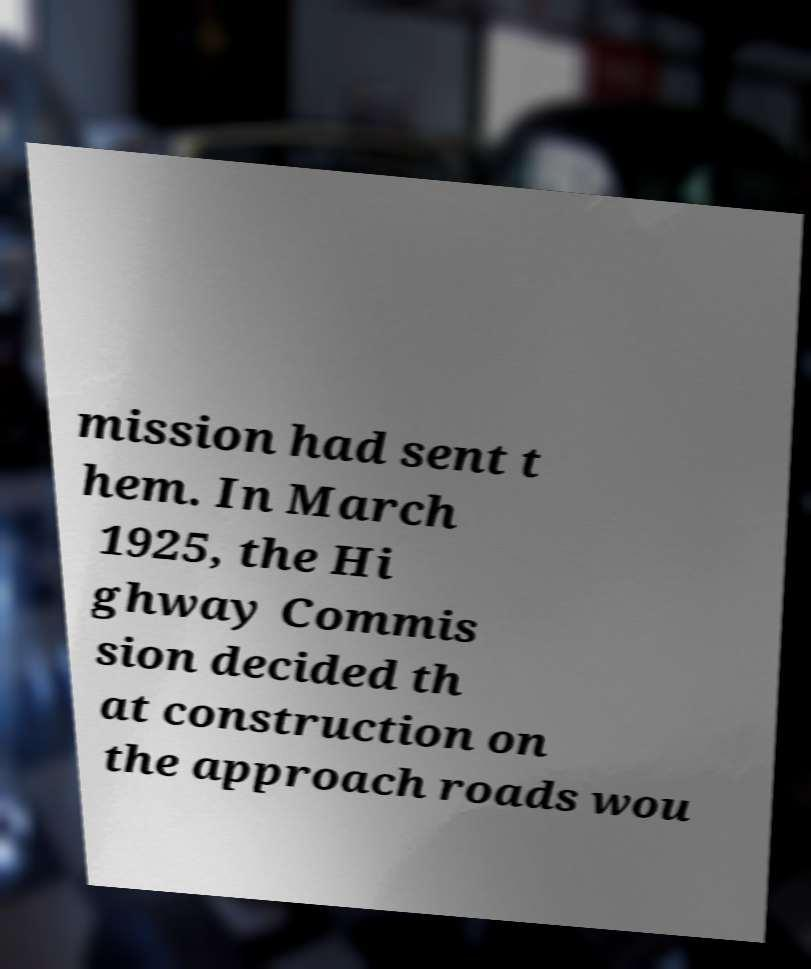I need the written content from this picture converted into text. Can you do that? mission had sent t hem. In March 1925, the Hi ghway Commis sion decided th at construction on the approach roads wou 